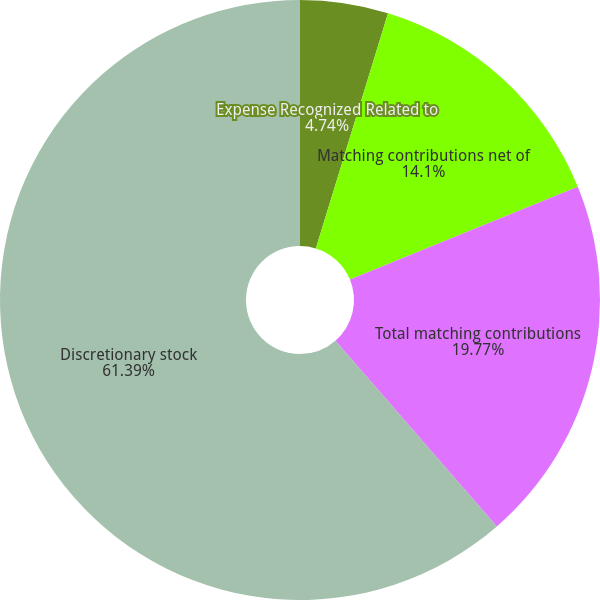Convert chart. <chart><loc_0><loc_0><loc_500><loc_500><pie_chart><fcel>Expense Recognized Related to<fcel>Matching contributions net of<fcel>Total matching contributions<fcel>Discretionary stock<nl><fcel>4.74%<fcel>14.1%<fcel>19.77%<fcel>61.39%<nl></chart> 